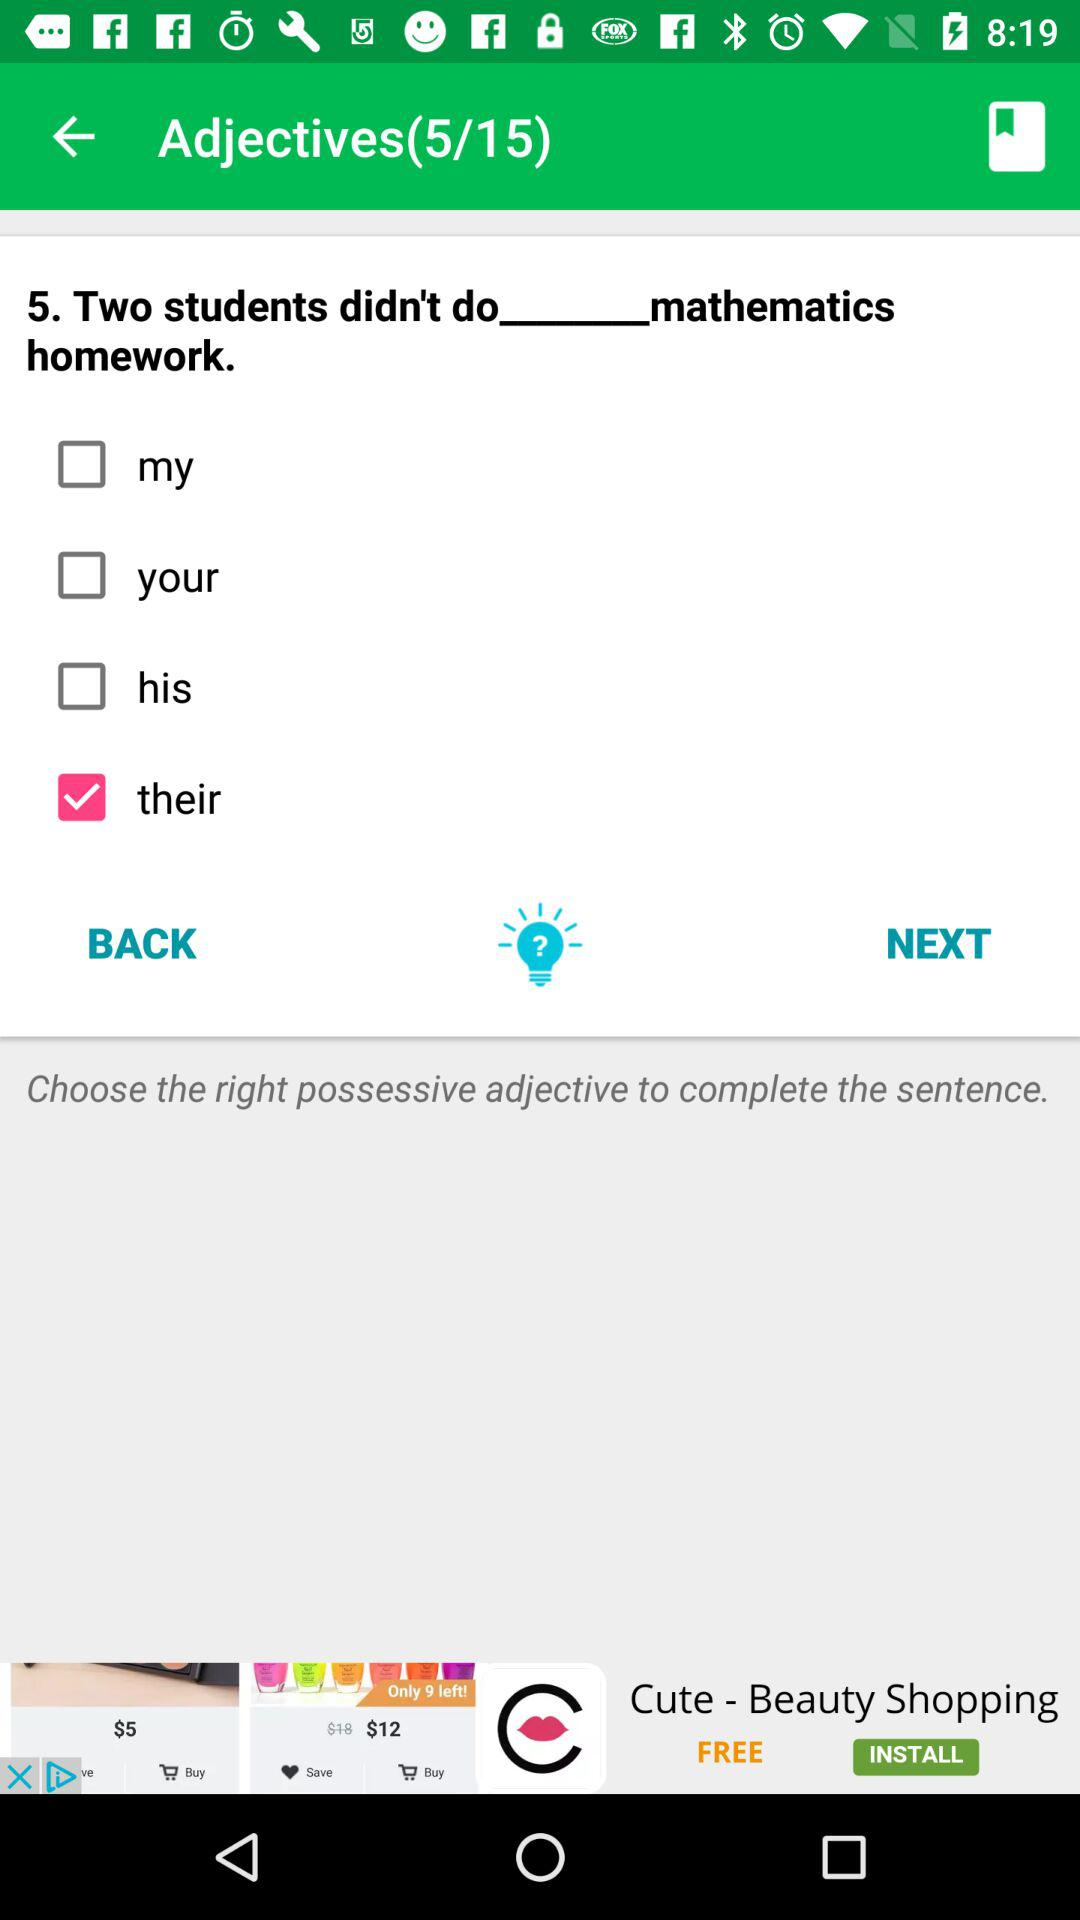How many possessive adjectives are there? 4 